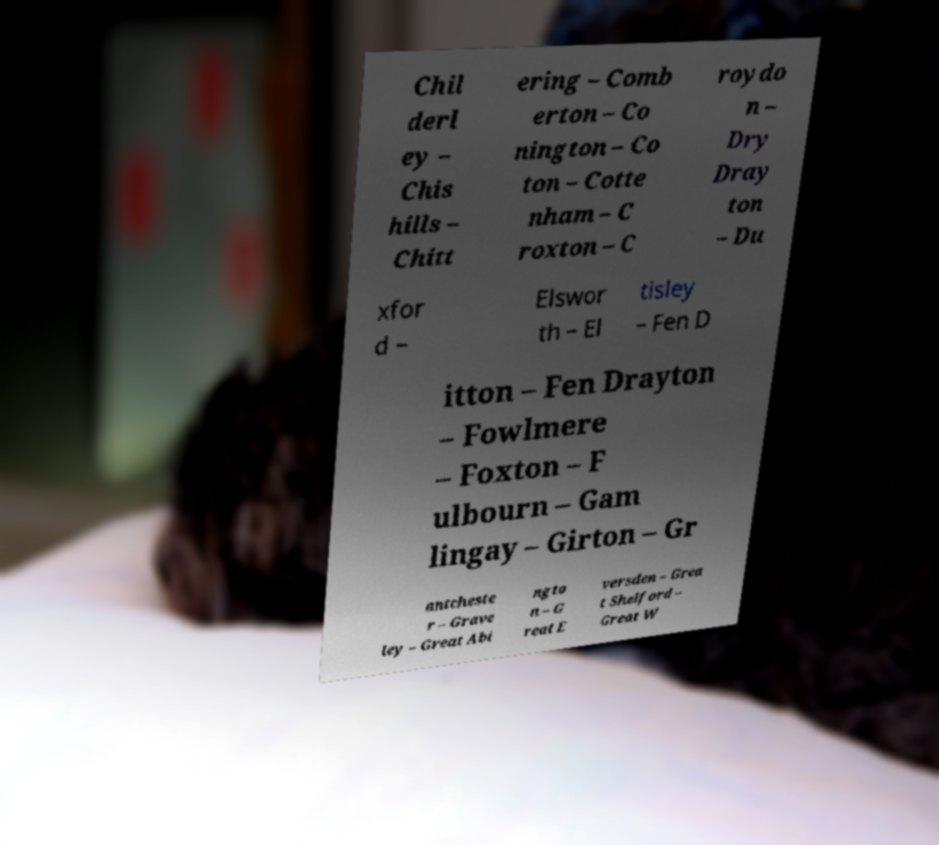What messages or text are displayed in this image? I need them in a readable, typed format. Chil derl ey – Chis hills – Chitt ering – Comb erton – Co nington – Co ton – Cotte nham – C roxton – C roydo n – Dry Dray ton – Du xfor d – Elswor th – El tisley – Fen D itton – Fen Drayton – Fowlmere – Foxton – F ulbourn – Gam lingay – Girton – Gr antcheste r – Grave ley – Great Abi ngto n – G reat E versden – Grea t Shelford – Great W 